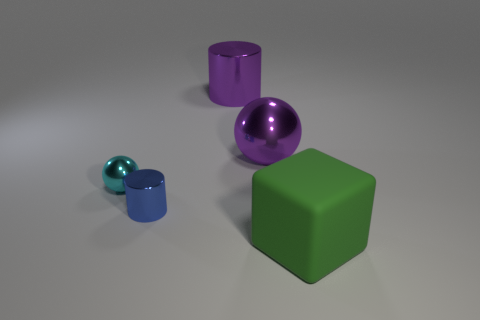Does the big ball have the same color as the large metallic cylinder?
Offer a terse response. Yes. What shape is the metallic object that is on the left side of the metal object in front of the small metallic thing that is left of the blue thing?
Offer a terse response. Sphere. What number of other objects are there of the same shape as the tiny blue thing?
Offer a terse response. 1. There is a metallic sphere that is the same size as the green thing; what color is it?
Offer a very short reply. Purple. Is the number of purple balls in front of the cyan object the same as the number of purple matte spheres?
Provide a succinct answer. Yes. What is the shape of the thing that is both to the left of the purple metal sphere and in front of the cyan metallic object?
Offer a terse response. Cylinder. Does the green object have the same size as the purple metallic ball?
Ensure brevity in your answer.  Yes. Is there a small blue cylinder that has the same material as the blue object?
Provide a succinct answer. No. What is the size of the cylinder that is the same color as the large metallic ball?
Offer a terse response. Large. How many big things are both behind the cyan object and on the right side of the large cylinder?
Your answer should be compact. 1. 